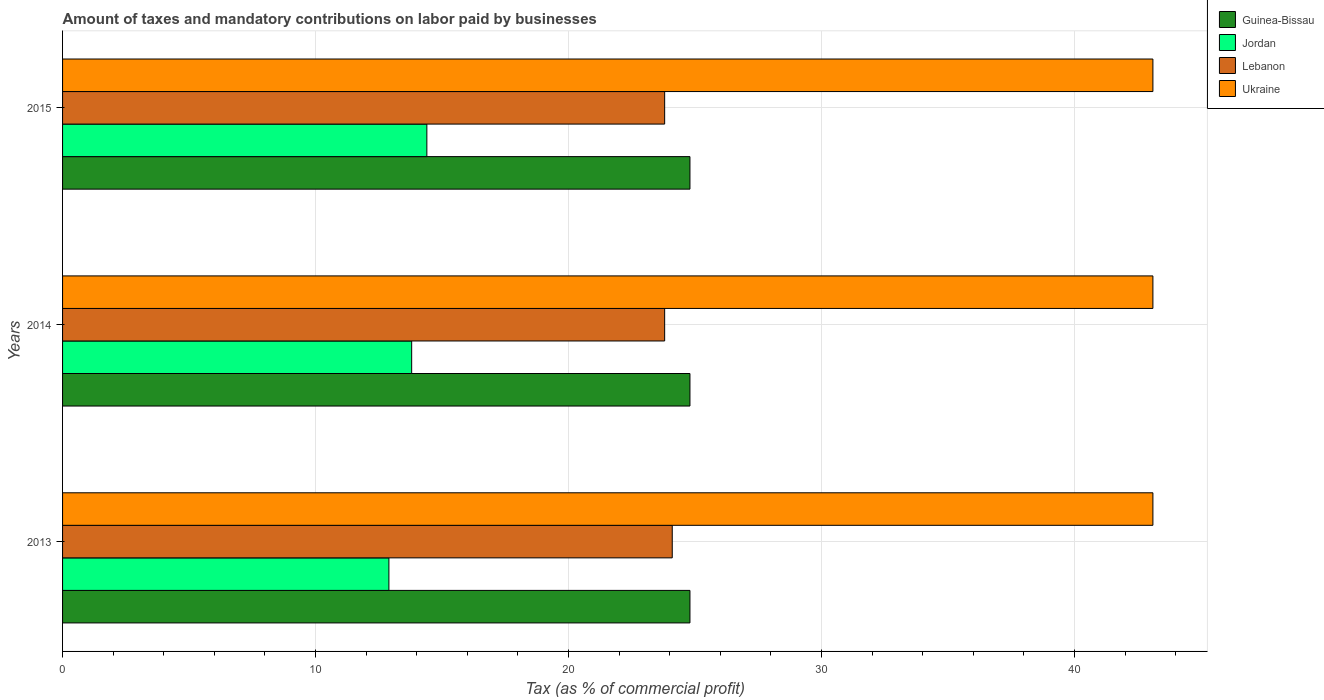How many different coloured bars are there?
Give a very brief answer. 4. How many groups of bars are there?
Provide a short and direct response. 3. Are the number of bars on each tick of the Y-axis equal?
Provide a short and direct response. Yes. What is the label of the 1st group of bars from the top?
Your answer should be compact. 2015. In how many cases, is the number of bars for a given year not equal to the number of legend labels?
Your answer should be compact. 0. What is the percentage of taxes paid by businesses in Lebanon in 2013?
Your answer should be compact. 24.1. Across all years, what is the maximum percentage of taxes paid by businesses in Lebanon?
Provide a succinct answer. 24.1. Across all years, what is the minimum percentage of taxes paid by businesses in Ukraine?
Give a very brief answer. 43.1. In which year was the percentage of taxes paid by businesses in Lebanon maximum?
Offer a terse response. 2013. In which year was the percentage of taxes paid by businesses in Lebanon minimum?
Your answer should be compact. 2014. What is the total percentage of taxes paid by businesses in Guinea-Bissau in the graph?
Give a very brief answer. 74.4. What is the difference between the percentage of taxes paid by businesses in Lebanon in 2014 and the percentage of taxes paid by businesses in Ukraine in 2015?
Keep it short and to the point. -19.3. What is the average percentage of taxes paid by businesses in Lebanon per year?
Make the answer very short. 23.9. In how many years, is the percentage of taxes paid by businesses in Jordan greater than 22 %?
Provide a short and direct response. 0. Is the difference between the percentage of taxes paid by businesses in Guinea-Bissau in 2014 and 2015 greater than the difference between the percentage of taxes paid by businesses in Lebanon in 2014 and 2015?
Your answer should be compact. No. What is the difference between the highest and the second highest percentage of taxes paid by businesses in Ukraine?
Your answer should be compact. 0. What is the difference between the highest and the lowest percentage of taxes paid by businesses in Lebanon?
Your answer should be very brief. 0.3. Is it the case that in every year, the sum of the percentage of taxes paid by businesses in Ukraine and percentage of taxes paid by businesses in Jordan is greater than the sum of percentage of taxes paid by businesses in Guinea-Bissau and percentage of taxes paid by businesses in Lebanon?
Give a very brief answer. Yes. What does the 1st bar from the top in 2014 represents?
Your answer should be compact. Ukraine. What does the 2nd bar from the bottom in 2015 represents?
Offer a terse response. Jordan. How many bars are there?
Offer a very short reply. 12. Are all the bars in the graph horizontal?
Your response must be concise. Yes. What is the title of the graph?
Offer a terse response. Amount of taxes and mandatory contributions on labor paid by businesses. What is the label or title of the X-axis?
Offer a terse response. Tax (as % of commercial profit). What is the label or title of the Y-axis?
Your response must be concise. Years. What is the Tax (as % of commercial profit) of Guinea-Bissau in 2013?
Provide a short and direct response. 24.8. What is the Tax (as % of commercial profit) of Lebanon in 2013?
Provide a short and direct response. 24.1. What is the Tax (as % of commercial profit) of Ukraine in 2013?
Offer a terse response. 43.1. What is the Tax (as % of commercial profit) of Guinea-Bissau in 2014?
Your answer should be compact. 24.8. What is the Tax (as % of commercial profit) in Lebanon in 2014?
Your response must be concise. 23.8. What is the Tax (as % of commercial profit) in Ukraine in 2014?
Provide a short and direct response. 43.1. What is the Tax (as % of commercial profit) in Guinea-Bissau in 2015?
Your answer should be compact. 24.8. What is the Tax (as % of commercial profit) in Lebanon in 2015?
Ensure brevity in your answer.  23.8. What is the Tax (as % of commercial profit) in Ukraine in 2015?
Offer a very short reply. 43.1. Across all years, what is the maximum Tax (as % of commercial profit) of Guinea-Bissau?
Provide a succinct answer. 24.8. Across all years, what is the maximum Tax (as % of commercial profit) of Jordan?
Your answer should be very brief. 14.4. Across all years, what is the maximum Tax (as % of commercial profit) in Lebanon?
Your answer should be very brief. 24.1. Across all years, what is the maximum Tax (as % of commercial profit) of Ukraine?
Offer a terse response. 43.1. Across all years, what is the minimum Tax (as % of commercial profit) of Guinea-Bissau?
Offer a very short reply. 24.8. Across all years, what is the minimum Tax (as % of commercial profit) in Lebanon?
Ensure brevity in your answer.  23.8. Across all years, what is the minimum Tax (as % of commercial profit) in Ukraine?
Offer a very short reply. 43.1. What is the total Tax (as % of commercial profit) of Guinea-Bissau in the graph?
Your answer should be compact. 74.4. What is the total Tax (as % of commercial profit) in Jordan in the graph?
Provide a short and direct response. 41.1. What is the total Tax (as % of commercial profit) of Lebanon in the graph?
Provide a succinct answer. 71.7. What is the total Tax (as % of commercial profit) in Ukraine in the graph?
Ensure brevity in your answer.  129.3. What is the difference between the Tax (as % of commercial profit) in Guinea-Bissau in 2013 and that in 2014?
Give a very brief answer. 0. What is the difference between the Tax (as % of commercial profit) of Jordan in 2013 and that in 2015?
Provide a short and direct response. -1.5. What is the difference between the Tax (as % of commercial profit) in Lebanon in 2013 and that in 2015?
Keep it short and to the point. 0.3. What is the difference between the Tax (as % of commercial profit) of Guinea-Bissau in 2014 and that in 2015?
Provide a short and direct response. 0. What is the difference between the Tax (as % of commercial profit) of Ukraine in 2014 and that in 2015?
Your answer should be compact. 0. What is the difference between the Tax (as % of commercial profit) in Guinea-Bissau in 2013 and the Tax (as % of commercial profit) in Jordan in 2014?
Keep it short and to the point. 11. What is the difference between the Tax (as % of commercial profit) of Guinea-Bissau in 2013 and the Tax (as % of commercial profit) of Ukraine in 2014?
Ensure brevity in your answer.  -18.3. What is the difference between the Tax (as % of commercial profit) in Jordan in 2013 and the Tax (as % of commercial profit) in Ukraine in 2014?
Offer a terse response. -30.2. What is the difference between the Tax (as % of commercial profit) in Guinea-Bissau in 2013 and the Tax (as % of commercial profit) in Jordan in 2015?
Give a very brief answer. 10.4. What is the difference between the Tax (as % of commercial profit) of Guinea-Bissau in 2013 and the Tax (as % of commercial profit) of Lebanon in 2015?
Provide a succinct answer. 1. What is the difference between the Tax (as % of commercial profit) of Guinea-Bissau in 2013 and the Tax (as % of commercial profit) of Ukraine in 2015?
Your response must be concise. -18.3. What is the difference between the Tax (as % of commercial profit) of Jordan in 2013 and the Tax (as % of commercial profit) of Lebanon in 2015?
Provide a succinct answer. -10.9. What is the difference between the Tax (as % of commercial profit) in Jordan in 2013 and the Tax (as % of commercial profit) in Ukraine in 2015?
Provide a succinct answer. -30.2. What is the difference between the Tax (as % of commercial profit) in Lebanon in 2013 and the Tax (as % of commercial profit) in Ukraine in 2015?
Your answer should be very brief. -19. What is the difference between the Tax (as % of commercial profit) of Guinea-Bissau in 2014 and the Tax (as % of commercial profit) of Ukraine in 2015?
Provide a short and direct response. -18.3. What is the difference between the Tax (as % of commercial profit) in Jordan in 2014 and the Tax (as % of commercial profit) in Lebanon in 2015?
Your answer should be very brief. -10. What is the difference between the Tax (as % of commercial profit) of Jordan in 2014 and the Tax (as % of commercial profit) of Ukraine in 2015?
Provide a succinct answer. -29.3. What is the difference between the Tax (as % of commercial profit) of Lebanon in 2014 and the Tax (as % of commercial profit) of Ukraine in 2015?
Provide a short and direct response. -19.3. What is the average Tax (as % of commercial profit) of Guinea-Bissau per year?
Provide a short and direct response. 24.8. What is the average Tax (as % of commercial profit) in Jordan per year?
Offer a terse response. 13.7. What is the average Tax (as % of commercial profit) in Lebanon per year?
Your answer should be compact. 23.9. What is the average Tax (as % of commercial profit) in Ukraine per year?
Offer a terse response. 43.1. In the year 2013, what is the difference between the Tax (as % of commercial profit) of Guinea-Bissau and Tax (as % of commercial profit) of Lebanon?
Provide a succinct answer. 0.7. In the year 2013, what is the difference between the Tax (as % of commercial profit) in Guinea-Bissau and Tax (as % of commercial profit) in Ukraine?
Your response must be concise. -18.3. In the year 2013, what is the difference between the Tax (as % of commercial profit) in Jordan and Tax (as % of commercial profit) in Ukraine?
Make the answer very short. -30.2. In the year 2014, what is the difference between the Tax (as % of commercial profit) in Guinea-Bissau and Tax (as % of commercial profit) in Lebanon?
Your response must be concise. 1. In the year 2014, what is the difference between the Tax (as % of commercial profit) of Guinea-Bissau and Tax (as % of commercial profit) of Ukraine?
Provide a succinct answer. -18.3. In the year 2014, what is the difference between the Tax (as % of commercial profit) of Jordan and Tax (as % of commercial profit) of Ukraine?
Offer a terse response. -29.3. In the year 2014, what is the difference between the Tax (as % of commercial profit) of Lebanon and Tax (as % of commercial profit) of Ukraine?
Your response must be concise. -19.3. In the year 2015, what is the difference between the Tax (as % of commercial profit) of Guinea-Bissau and Tax (as % of commercial profit) of Lebanon?
Give a very brief answer. 1. In the year 2015, what is the difference between the Tax (as % of commercial profit) in Guinea-Bissau and Tax (as % of commercial profit) in Ukraine?
Ensure brevity in your answer.  -18.3. In the year 2015, what is the difference between the Tax (as % of commercial profit) in Jordan and Tax (as % of commercial profit) in Lebanon?
Offer a terse response. -9.4. In the year 2015, what is the difference between the Tax (as % of commercial profit) in Jordan and Tax (as % of commercial profit) in Ukraine?
Your answer should be compact. -28.7. In the year 2015, what is the difference between the Tax (as % of commercial profit) of Lebanon and Tax (as % of commercial profit) of Ukraine?
Keep it short and to the point. -19.3. What is the ratio of the Tax (as % of commercial profit) in Jordan in 2013 to that in 2014?
Your response must be concise. 0.93. What is the ratio of the Tax (as % of commercial profit) in Lebanon in 2013 to that in 2014?
Offer a very short reply. 1.01. What is the ratio of the Tax (as % of commercial profit) in Ukraine in 2013 to that in 2014?
Give a very brief answer. 1. What is the ratio of the Tax (as % of commercial profit) of Guinea-Bissau in 2013 to that in 2015?
Your answer should be compact. 1. What is the ratio of the Tax (as % of commercial profit) in Jordan in 2013 to that in 2015?
Offer a terse response. 0.9. What is the ratio of the Tax (as % of commercial profit) of Lebanon in 2013 to that in 2015?
Your answer should be compact. 1.01. What is the ratio of the Tax (as % of commercial profit) in Ukraine in 2013 to that in 2015?
Ensure brevity in your answer.  1. What is the ratio of the Tax (as % of commercial profit) of Guinea-Bissau in 2014 to that in 2015?
Ensure brevity in your answer.  1. What is the ratio of the Tax (as % of commercial profit) in Jordan in 2014 to that in 2015?
Offer a terse response. 0.96. What is the difference between the highest and the second highest Tax (as % of commercial profit) in Guinea-Bissau?
Ensure brevity in your answer.  0. What is the difference between the highest and the second highest Tax (as % of commercial profit) in Jordan?
Provide a short and direct response. 0.6. What is the difference between the highest and the second highest Tax (as % of commercial profit) of Lebanon?
Offer a very short reply. 0.3. What is the difference between the highest and the lowest Tax (as % of commercial profit) in Guinea-Bissau?
Your answer should be compact. 0. What is the difference between the highest and the lowest Tax (as % of commercial profit) of Lebanon?
Offer a very short reply. 0.3. 